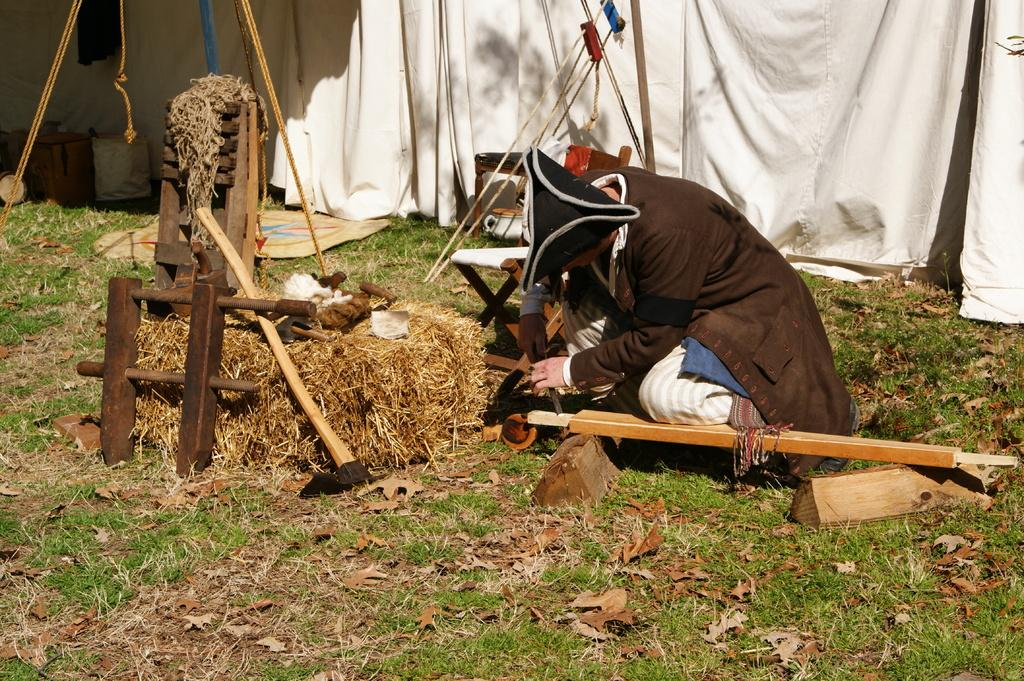Who or what is present in the image? There is a person in the image. What is the person wearing? The person is wearing a brown coat and a cap. What type of material can be seen in the image? There is wood and a rope in the image. What structure is visible in the image? There is a white tent in the image. What type of poisonous creature can be seen in the image? There is no poisonous creature present in the image. What type of toad is sitting on the person's shoulder in the image? There is no toad present in the image. 